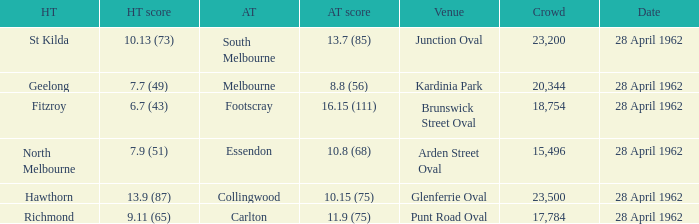What away team played at Brunswick Street Oval? Footscray. 